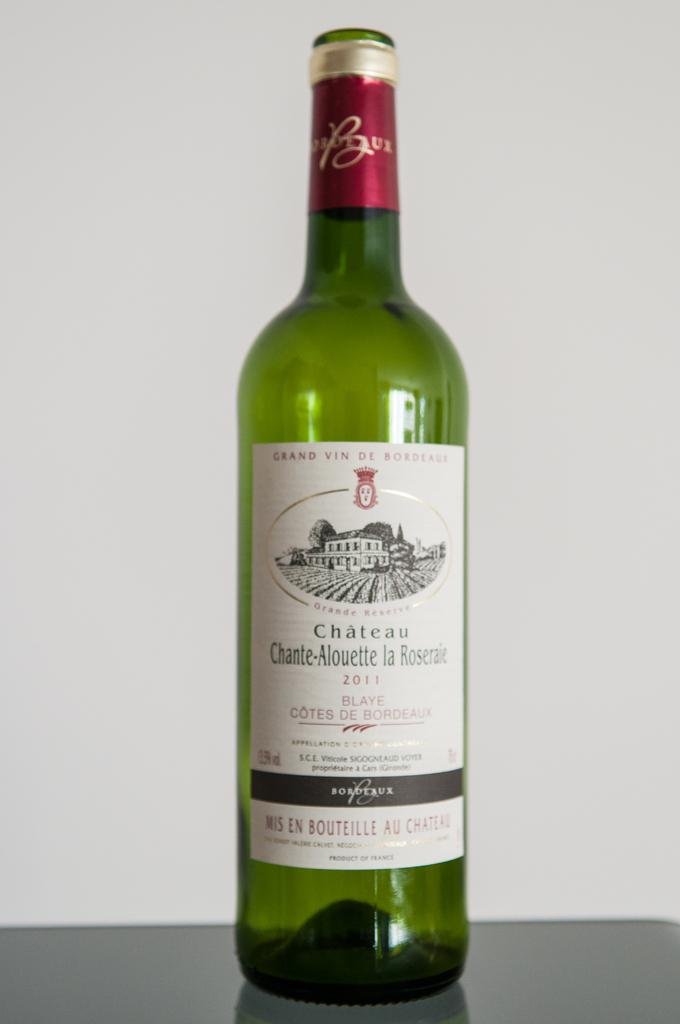Provide a one-sentence caption for the provided image. a bottle of wine with a label on it that says 'chateu chante-alouette la roserae'. 